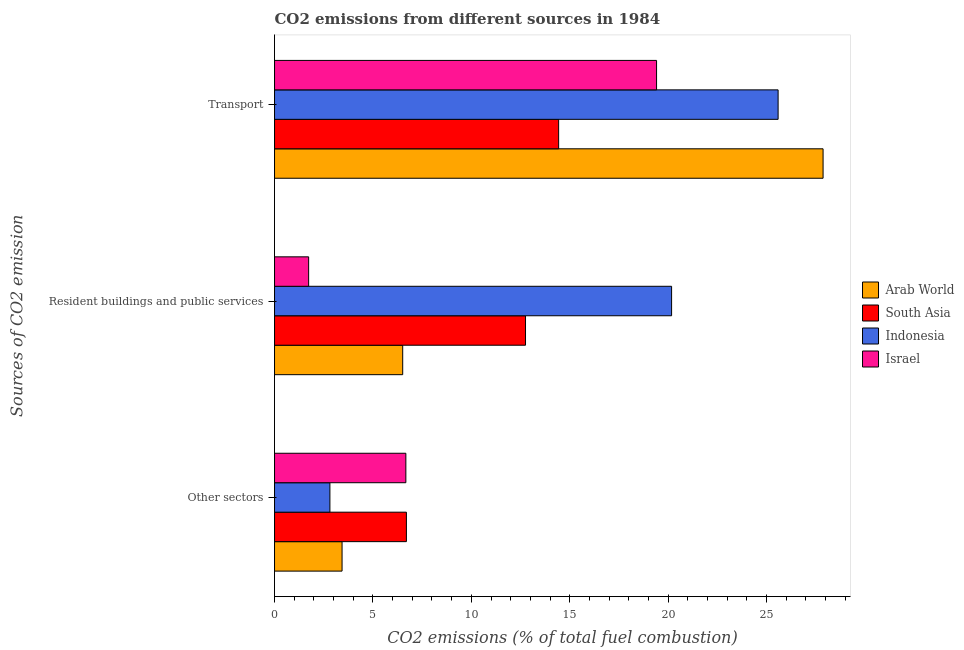How many groups of bars are there?
Your response must be concise. 3. Are the number of bars per tick equal to the number of legend labels?
Your response must be concise. Yes. What is the label of the 1st group of bars from the top?
Provide a succinct answer. Transport. What is the percentage of co2 emissions from other sectors in Israel?
Keep it short and to the point. 6.67. Across all countries, what is the maximum percentage of co2 emissions from resident buildings and public services?
Your answer should be very brief. 20.17. Across all countries, what is the minimum percentage of co2 emissions from other sectors?
Give a very brief answer. 2.81. What is the total percentage of co2 emissions from resident buildings and public services in the graph?
Give a very brief answer. 41.17. What is the difference between the percentage of co2 emissions from other sectors in Indonesia and that in Israel?
Offer a terse response. -3.86. What is the difference between the percentage of co2 emissions from resident buildings and public services in Indonesia and the percentage of co2 emissions from other sectors in South Asia?
Keep it short and to the point. 13.47. What is the average percentage of co2 emissions from transport per country?
Provide a short and direct response. 21.83. What is the difference between the percentage of co2 emissions from resident buildings and public services and percentage of co2 emissions from transport in Arab World?
Keep it short and to the point. -21.36. In how many countries, is the percentage of co2 emissions from transport greater than 25 %?
Your answer should be very brief. 2. What is the ratio of the percentage of co2 emissions from other sectors in Arab World to that in South Asia?
Give a very brief answer. 0.51. Is the percentage of co2 emissions from resident buildings and public services in Israel less than that in South Asia?
Offer a terse response. Yes. Is the difference between the percentage of co2 emissions from transport in Arab World and Indonesia greater than the difference between the percentage of co2 emissions from resident buildings and public services in Arab World and Indonesia?
Make the answer very short. Yes. What is the difference between the highest and the second highest percentage of co2 emissions from resident buildings and public services?
Give a very brief answer. 7.42. What is the difference between the highest and the lowest percentage of co2 emissions from transport?
Offer a very short reply. 13.44. In how many countries, is the percentage of co2 emissions from other sectors greater than the average percentage of co2 emissions from other sectors taken over all countries?
Your response must be concise. 2. What does the 4th bar from the top in Resident buildings and public services represents?
Make the answer very short. Arab World. What does the 1st bar from the bottom in Resident buildings and public services represents?
Keep it short and to the point. Arab World. Is it the case that in every country, the sum of the percentage of co2 emissions from other sectors and percentage of co2 emissions from resident buildings and public services is greater than the percentage of co2 emissions from transport?
Keep it short and to the point. No. How many bars are there?
Offer a very short reply. 12. What is the difference between two consecutive major ticks on the X-axis?
Keep it short and to the point. 5. Does the graph contain any zero values?
Provide a short and direct response. No. Does the graph contain grids?
Offer a very short reply. No. Where does the legend appear in the graph?
Offer a terse response. Center right. How many legend labels are there?
Your answer should be compact. 4. How are the legend labels stacked?
Provide a succinct answer. Vertical. What is the title of the graph?
Ensure brevity in your answer.  CO2 emissions from different sources in 1984. What is the label or title of the X-axis?
Keep it short and to the point. CO2 emissions (% of total fuel combustion). What is the label or title of the Y-axis?
Offer a very short reply. Sources of CO2 emission. What is the CO2 emissions (% of total fuel combustion) in Arab World in Other sectors?
Give a very brief answer. 3.43. What is the CO2 emissions (% of total fuel combustion) in South Asia in Other sectors?
Offer a very short reply. 6.7. What is the CO2 emissions (% of total fuel combustion) in Indonesia in Other sectors?
Offer a terse response. 2.81. What is the CO2 emissions (% of total fuel combustion) in Israel in Other sectors?
Provide a succinct answer. 6.67. What is the CO2 emissions (% of total fuel combustion) of Arab World in Resident buildings and public services?
Your answer should be very brief. 6.51. What is the CO2 emissions (% of total fuel combustion) in South Asia in Resident buildings and public services?
Your answer should be very brief. 12.75. What is the CO2 emissions (% of total fuel combustion) of Indonesia in Resident buildings and public services?
Give a very brief answer. 20.17. What is the CO2 emissions (% of total fuel combustion) of Israel in Resident buildings and public services?
Keep it short and to the point. 1.73. What is the CO2 emissions (% of total fuel combustion) in Arab World in Transport?
Your response must be concise. 27.87. What is the CO2 emissions (% of total fuel combustion) in South Asia in Transport?
Your answer should be compact. 14.44. What is the CO2 emissions (% of total fuel combustion) of Indonesia in Transport?
Provide a short and direct response. 25.59. What is the CO2 emissions (% of total fuel combustion) of Israel in Transport?
Your response must be concise. 19.41. Across all Sources of CO2 emission, what is the maximum CO2 emissions (% of total fuel combustion) in Arab World?
Provide a succinct answer. 27.87. Across all Sources of CO2 emission, what is the maximum CO2 emissions (% of total fuel combustion) in South Asia?
Offer a terse response. 14.44. Across all Sources of CO2 emission, what is the maximum CO2 emissions (% of total fuel combustion) in Indonesia?
Your answer should be compact. 25.59. Across all Sources of CO2 emission, what is the maximum CO2 emissions (% of total fuel combustion) of Israel?
Make the answer very short. 19.41. Across all Sources of CO2 emission, what is the minimum CO2 emissions (% of total fuel combustion) of Arab World?
Give a very brief answer. 3.43. Across all Sources of CO2 emission, what is the minimum CO2 emissions (% of total fuel combustion) of South Asia?
Your answer should be very brief. 6.7. Across all Sources of CO2 emission, what is the minimum CO2 emissions (% of total fuel combustion) of Indonesia?
Give a very brief answer. 2.81. Across all Sources of CO2 emission, what is the minimum CO2 emissions (% of total fuel combustion) in Israel?
Provide a short and direct response. 1.73. What is the total CO2 emissions (% of total fuel combustion) of Arab World in the graph?
Give a very brief answer. 37.81. What is the total CO2 emissions (% of total fuel combustion) in South Asia in the graph?
Keep it short and to the point. 33.89. What is the total CO2 emissions (% of total fuel combustion) of Indonesia in the graph?
Your answer should be very brief. 48.57. What is the total CO2 emissions (% of total fuel combustion) in Israel in the graph?
Your response must be concise. 27.82. What is the difference between the CO2 emissions (% of total fuel combustion) of Arab World in Other sectors and that in Resident buildings and public services?
Your answer should be very brief. -3.08. What is the difference between the CO2 emissions (% of total fuel combustion) of South Asia in Other sectors and that in Resident buildings and public services?
Make the answer very short. -6.05. What is the difference between the CO2 emissions (% of total fuel combustion) of Indonesia in Other sectors and that in Resident buildings and public services?
Give a very brief answer. -17.36. What is the difference between the CO2 emissions (% of total fuel combustion) in Israel in Other sectors and that in Resident buildings and public services?
Keep it short and to the point. 4.94. What is the difference between the CO2 emissions (% of total fuel combustion) of Arab World in Other sectors and that in Transport?
Provide a short and direct response. -24.44. What is the difference between the CO2 emissions (% of total fuel combustion) in South Asia in Other sectors and that in Transport?
Your response must be concise. -7.73. What is the difference between the CO2 emissions (% of total fuel combustion) of Indonesia in Other sectors and that in Transport?
Your answer should be very brief. -22.77. What is the difference between the CO2 emissions (% of total fuel combustion) of Israel in Other sectors and that in Transport?
Keep it short and to the point. -12.74. What is the difference between the CO2 emissions (% of total fuel combustion) of Arab World in Resident buildings and public services and that in Transport?
Give a very brief answer. -21.36. What is the difference between the CO2 emissions (% of total fuel combustion) in South Asia in Resident buildings and public services and that in Transport?
Give a very brief answer. -1.68. What is the difference between the CO2 emissions (% of total fuel combustion) of Indonesia in Resident buildings and public services and that in Transport?
Offer a terse response. -5.41. What is the difference between the CO2 emissions (% of total fuel combustion) in Israel in Resident buildings and public services and that in Transport?
Your answer should be very brief. -17.68. What is the difference between the CO2 emissions (% of total fuel combustion) of Arab World in Other sectors and the CO2 emissions (% of total fuel combustion) of South Asia in Resident buildings and public services?
Your answer should be very brief. -9.32. What is the difference between the CO2 emissions (% of total fuel combustion) in Arab World in Other sectors and the CO2 emissions (% of total fuel combustion) in Indonesia in Resident buildings and public services?
Provide a succinct answer. -16.74. What is the difference between the CO2 emissions (% of total fuel combustion) of Arab World in Other sectors and the CO2 emissions (% of total fuel combustion) of Israel in Resident buildings and public services?
Offer a very short reply. 1.7. What is the difference between the CO2 emissions (% of total fuel combustion) of South Asia in Other sectors and the CO2 emissions (% of total fuel combustion) of Indonesia in Resident buildings and public services?
Offer a terse response. -13.47. What is the difference between the CO2 emissions (% of total fuel combustion) in South Asia in Other sectors and the CO2 emissions (% of total fuel combustion) in Israel in Resident buildings and public services?
Your response must be concise. 4.97. What is the difference between the CO2 emissions (% of total fuel combustion) of Indonesia in Other sectors and the CO2 emissions (% of total fuel combustion) of Israel in Resident buildings and public services?
Provide a succinct answer. 1.08. What is the difference between the CO2 emissions (% of total fuel combustion) in Arab World in Other sectors and the CO2 emissions (% of total fuel combustion) in South Asia in Transport?
Your response must be concise. -11. What is the difference between the CO2 emissions (% of total fuel combustion) of Arab World in Other sectors and the CO2 emissions (% of total fuel combustion) of Indonesia in Transport?
Offer a very short reply. -22.16. What is the difference between the CO2 emissions (% of total fuel combustion) in Arab World in Other sectors and the CO2 emissions (% of total fuel combustion) in Israel in Transport?
Provide a succinct answer. -15.98. What is the difference between the CO2 emissions (% of total fuel combustion) of South Asia in Other sectors and the CO2 emissions (% of total fuel combustion) of Indonesia in Transport?
Give a very brief answer. -18.89. What is the difference between the CO2 emissions (% of total fuel combustion) in South Asia in Other sectors and the CO2 emissions (% of total fuel combustion) in Israel in Transport?
Offer a terse response. -12.71. What is the difference between the CO2 emissions (% of total fuel combustion) in Indonesia in Other sectors and the CO2 emissions (% of total fuel combustion) in Israel in Transport?
Make the answer very short. -16.6. What is the difference between the CO2 emissions (% of total fuel combustion) in Arab World in Resident buildings and public services and the CO2 emissions (% of total fuel combustion) in South Asia in Transport?
Give a very brief answer. -7.92. What is the difference between the CO2 emissions (% of total fuel combustion) in Arab World in Resident buildings and public services and the CO2 emissions (% of total fuel combustion) in Indonesia in Transport?
Your answer should be very brief. -19.07. What is the difference between the CO2 emissions (% of total fuel combustion) in Arab World in Resident buildings and public services and the CO2 emissions (% of total fuel combustion) in Israel in Transport?
Provide a succinct answer. -12.9. What is the difference between the CO2 emissions (% of total fuel combustion) of South Asia in Resident buildings and public services and the CO2 emissions (% of total fuel combustion) of Indonesia in Transport?
Your response must be concise. -12.83. What is the difference between the CO2 emissions (% of total fuel combustion) of South Asia in Resident buildings and public services and the CO2 emissions (% of total fuel combustion) of Israel in Transport?
Make the answer very short. -6.66. What is the difference between the CO2 emissions (% of total fuel combustion) of Indonesia in Resident buildings and public services and the CO2 emissions (% of total fuel combustion) of Israel in Transport?
Offer a very short reply. 0.76. What is the average CO2 emissions (% of total fuel combustion) of Arab World per Sources of CO2 emission?
Offer a terse response. 12.6. What is the average CO2 emissions (% of total fuel combustion) of South Asia per Sources of CO2 emission?
Offer a terse response. 11.3. What is the average CO2 emissions (% of total fuel combustion) in Indonesia per Sources of CO2 emission?
Keep it short and to the point. 16.19. What is the average CO2 emissions (% of total fuel combustion) in Israel per Sources of CO2 emission?
Offer a terse response. 9.27. What is the difference between the CO2 emissions (% of total fuel combustion) of Arab World and CO2 emissions (% of total fuel combustion) of South Asia in Other sectors?
Give a very brief answer. -3.27. What is the difference between the CO2 emissions (% of total fuel combustion) in Arab World and CO2 emissions (% of total fuel combustion) in Indonesia in Other sectors?
Provide a short and direct response. 0.62. What is the difference between the CO2 emissions (% of total fuel combustion) of Arab World and CO2 emissions (% of total fuel combustion) of Israel in Other sectors?
Provide a short and direct response. -3.24. What is the difference between the CO2 emissions (% of total fuel combustion) of South Asia and CO2 emissions (% of total fuel combustion) of Indonesia in Other sectors?
Your answer should be very brief. 3.89. What is the difference between the CO2 emissions (% of total fuel combustion) in South Asia and CO2 emissions (% of total fuel combustion) in Israel in Other sectors?
Provide a succinct answer. 0.03. What is the difference between the CO2 emissions (% of total fuel combustion) of Indonesia and CO2 emissions (% of total fuel combustion) of Israel in Other sectors?
Make the answer very short. -3.86. What is the difference between the CO2 emissions (% of total fuel combustion) of Arab World and CO2 emissions (% of total fuel combustion) of South Asia in Resident buildings and public services?
Offer a terse response. -6.24. What is the difference between the CO2 emissions (% of total fuel combustion) of Arab World and CO2 emissions (% of total fuel combustion) of Indonesia in Resident buildings and public services?
Your answer should be compact. -13.66. What is the difference between the CO2 emissions (% of total fuel combustion) in Arab World and CO2 emissions (% of total fuel combustion) in Israel in Resident buildings and public services?
Give a very brief answer. 4.78. What is the difference between the CO2 emissions (% of total fuel combustion) of South Asia and CO2 emissions (% of total fuel combustion) of Indonesia in Resident buildings and public services?
Make the answer very short. -7.42. What is the difference between the CO2 emissions (% of total fuel combustion) in South Asia and CO2 emissions (% of total fuel combustion) in Israel in Resident buildings and public services?
Give a very brief answer. 11.02. What is the difference between the CO2 emissions (% of total fuel combustion) in Indonesia and CO2 emissions (% of total fuel combustion) in Israel in Resident buildings and public services?
Your answer should be compact. 18.44. What is the difference between the CO2 emissions (% of total fuel combustion) of Arab World and CO2 emissions (% of total fuel combustion) of South Asia in Transport?
Ensure brevity in your answer.  13.44. What is the difference between the CO2 emissions (% of total fuel combustion) of Arab World and CO2 emissions (% of total fuel combustion) of Indonesia in Transport?
Make the answer very short. 2.28. What is the difference between the CO2 emissions (% of total fuel combustion) of Arab World and CO2 emissions (% of total fuel combustion) of Israel in Transport?
Your answer should be very brief. 8.46. What is the difference between the CO2 emissions (% of total fuel combustion) of South Asia and CO2 emissions (% of total fuel combustion) of Indonesia in Transport?
Offer a very short reply. -11.15. What is the difference between the CO2 emissions (% of total fuel combustion) of South Asia and CO2 emissions (% of total fuel combustion) of Israel in Transport?
Your answer should be very brief. -4.98. What is the difference between the CO2 emissions (% of total fuel combustion) of Indonesia and CO2 emissions (% of total fuel combustion) of Israel in Transport?
Your answer should be compact. 6.18. What is the ratio of the CO2 emissions (% of total fuel combustion) of Arab World in Other sectors to that in Resident buildings and public services?
Your response must be concise. 0.53. What is the ratio of the CO2 emissions (% of total fuel combustion) of South Asia in Other sectors to that in Resident buildings and public services?
Give a very brief answer. 0.53. What is the ratio of the CO2 emissions (% of total fuel combustion) of Indonesia in Other sectors to that in Resident buildings and public services?
Ensure brevity in your answer.  0.14. What is the ratio of the CO2 emissions (% of total fuel combustion) of Israel in Other sectors to that in Resident buildings and public services?
Offer a terse response. 3.85. What is the ratio of the CO2 emissions (% of total fuel combustion) of Arab World in Other sectors to that in Transport?
Make the answer very short. 0.12. What is the ratio of the CO2 emissions (% of total fuel combustion) in South Asia in Other sectors to that in Transport?
Offer a terse response. 0.46. What is the ratio of the CO2 emissions (% of total fuel combustion) in Indonesia in Other sectors to that in Transport?
Keep it short and to the point. 0.11. What is the ratio of the CO2 emissions (% of total fuel combustion) in Israel in Other sectors to that in Transport?
Ensure brevity in your answer.  0.34. What is the ratio of the CO2 emissions (% of total fuel combustion) in Arab World in Resident buildings and public services to that in Transport?
Provide a succinct answer. 0.23. What is the ratio of the CO2 emissions (% of total fuel combustion) of South Asia in Resident buildings and public services to that in Transport?
Ensure brevity in your answer.  0.88. What is the ratio of the CO2 emissions (% of total fuel combustion) of Indonesia in Resident buildings and public services to that in Transport?
Offer a terse response. 0.79. What is the ratio of the CO2 emissions (% of total fuel combustion) of Israel in Resident buildings and public services to that in Transport?
Your response must be concise. 0.09. What is the difference between the highest and the second highest CO2 emissions (% of total fuel combustion) in Arab World?
Offer a very short reply. 21.36. What is the difference between the highest and the second highest CO2 emissions (% of total fuel combustion) in South Asia?
Offer a very short reply. 1.68. What is the difference between the highest and the second highest CO2 emissions (% of total fuel combustion) in Indonesia?
Your answer should be compact. 5.41. What is the difference between the highest and the second highest CO2 emissions (% of total fuel combustion) in Israel?
Provide a succinct answer. 12.74. What is the difference between the highest and the lowest CO2 emissions (% of total fuel combustion) of Arab World?
Offer a terse response. 24.44. What is the difference between the highest and the lowest CO2 emissions (% of total fuel combustion) in South Asia?
Provide a succinct answer. 7.73. What is the difference between the highest and the lowest CO2 emissions (% of total fuel combustion) of Indonesia?
Make the answer very short. 22.77. What is the difference between the highest and the lowest CO2 emissions (% of total fuel combustion) in Israel?
Make the answer very short. 17.68. 